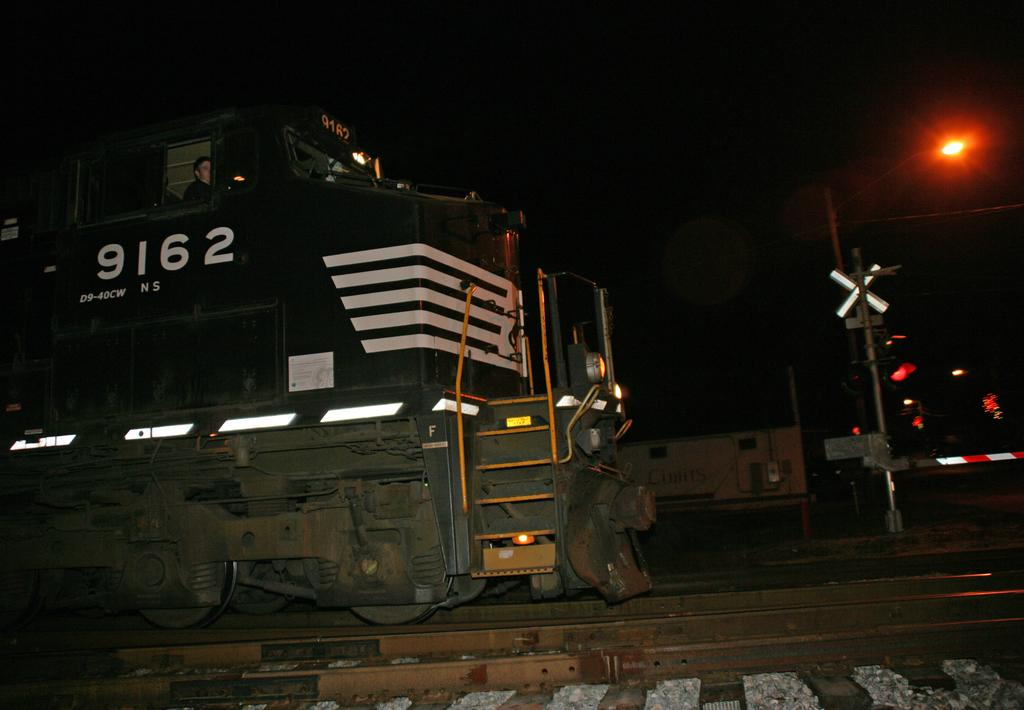What is the main subject of the image? The main subject of the image is a train. Where is the train located in the image? The train is on a railway track. What can be seen on the right side of the image? There is a pole on the right side of the image. What is the color of the light on the pole? The light on the pole is red. How would you describe the background of the image? The background of the image is dark. How many rabbits are sitting on the train in the image? There are no rabbits present in the image; it features a train on a railway track with a pole and a red light. What type of lamp is hanging from the door in the image? There is no lamp or door present in the image. 